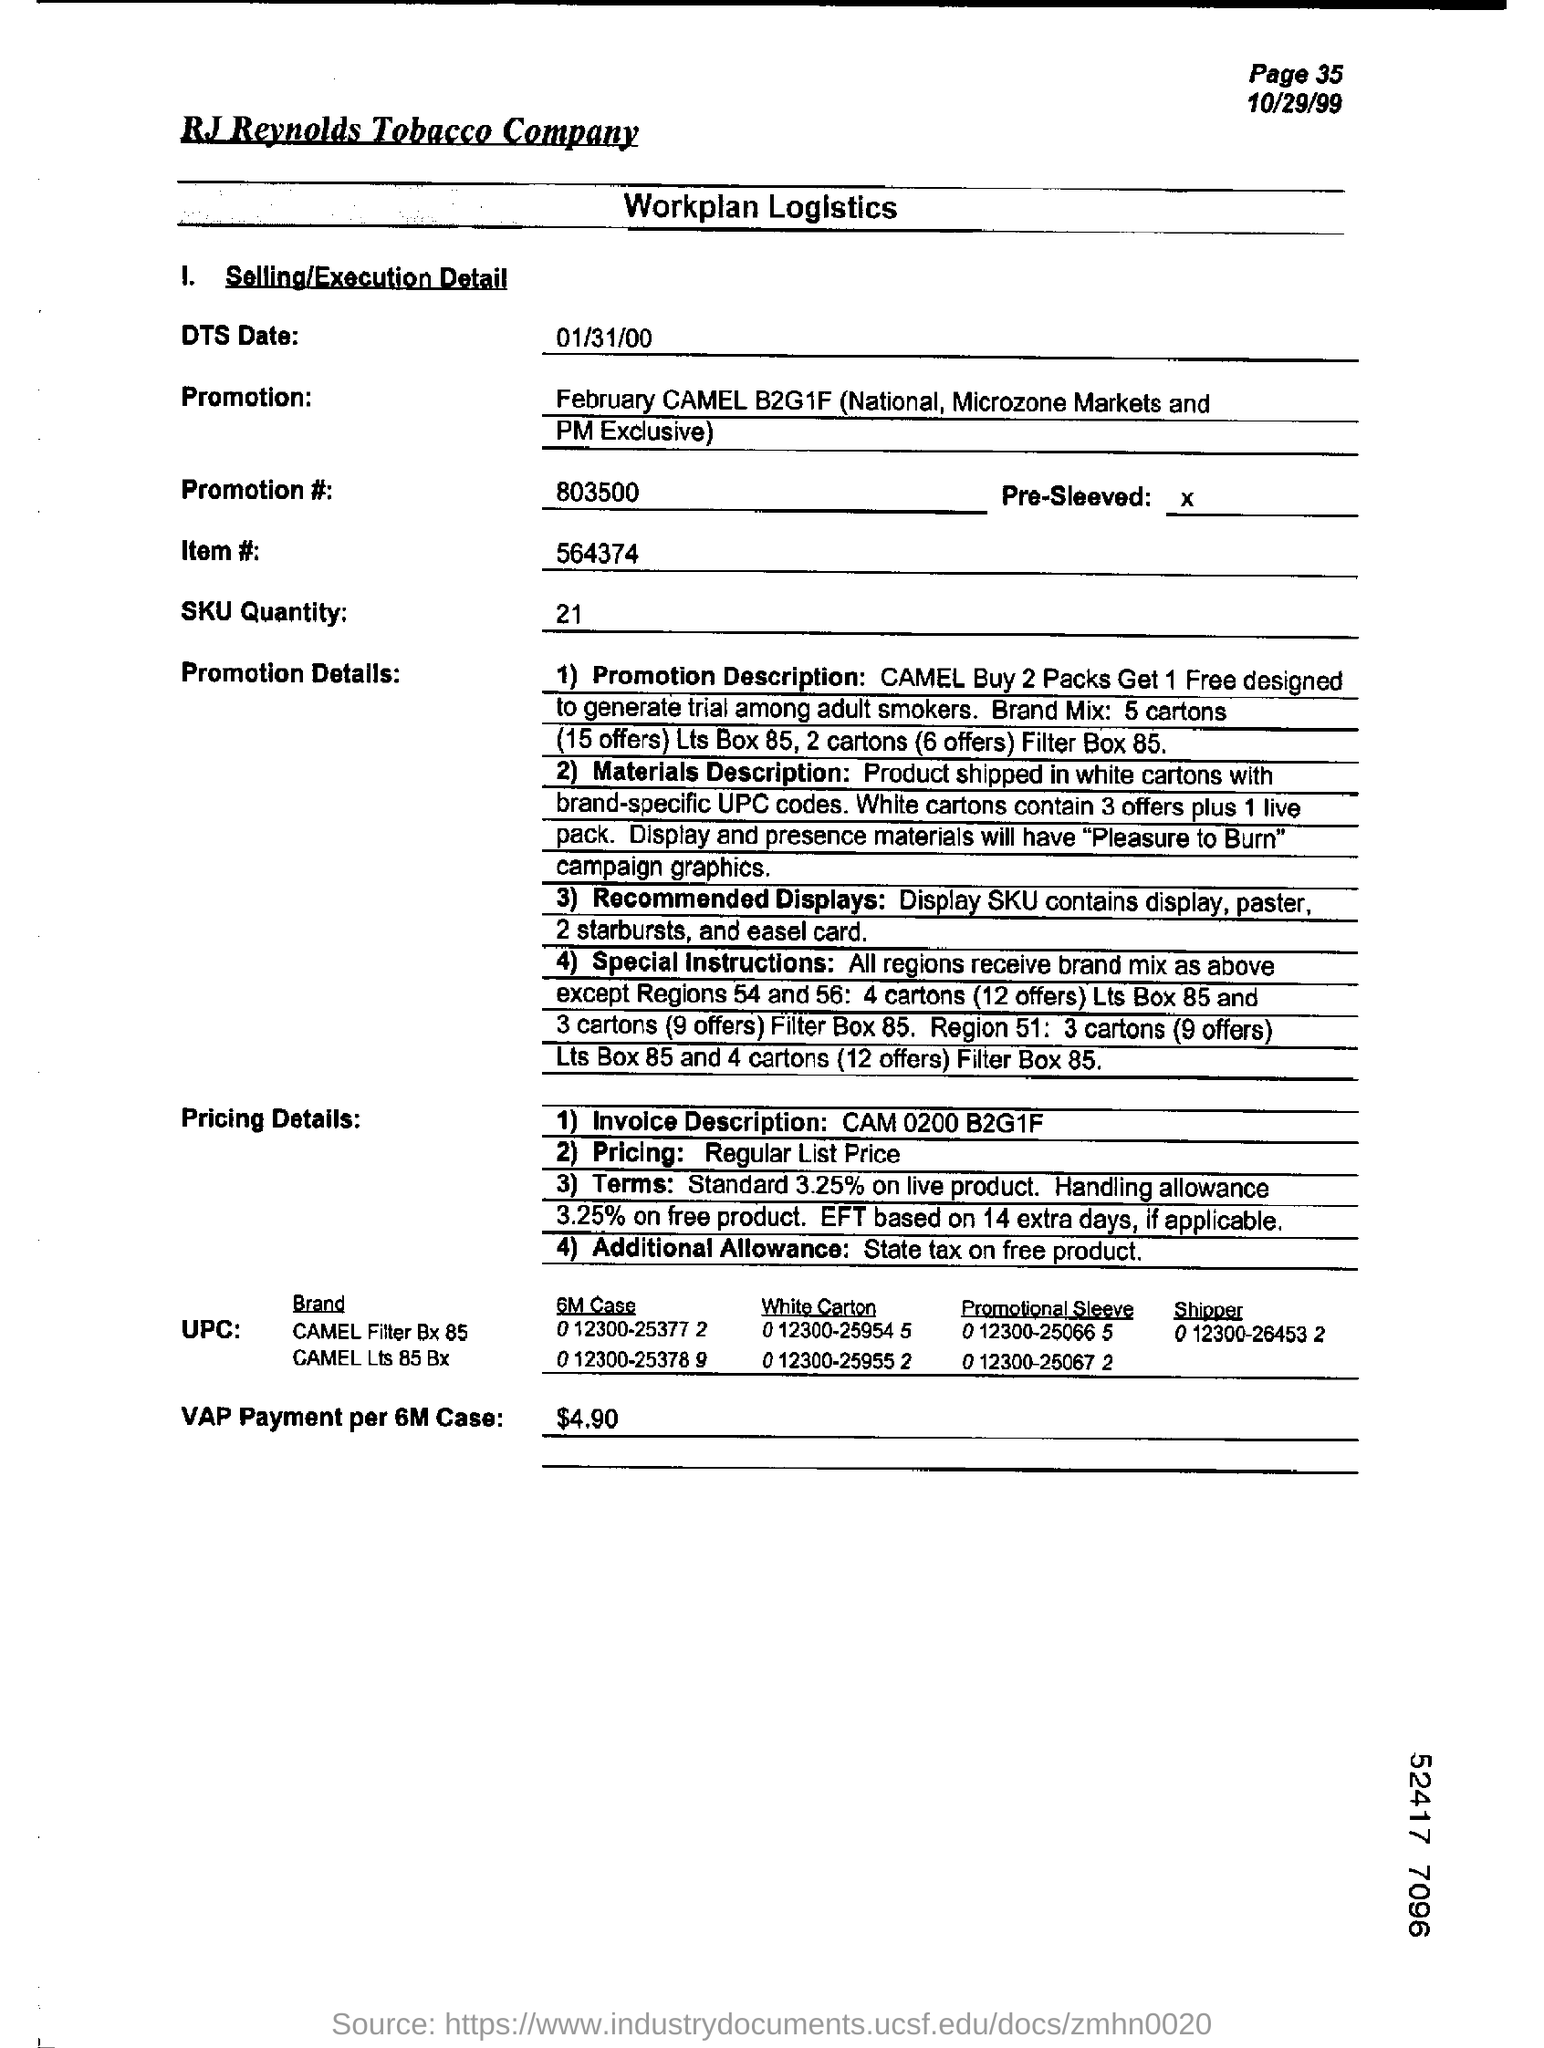Give some essential details in this illustration. The ITEM# mentioned in the document is 564374. The cost of the VAP (Vendor Application Payment) per case for a 6-month contract is $4.90. The document mentions a date, January 31st, 2000, which is referred to as the DTS Date. The workplan logistics for RJ Reynolds Tobacco Company are provided. The SKU quantity, as per the provided document, is 21. 